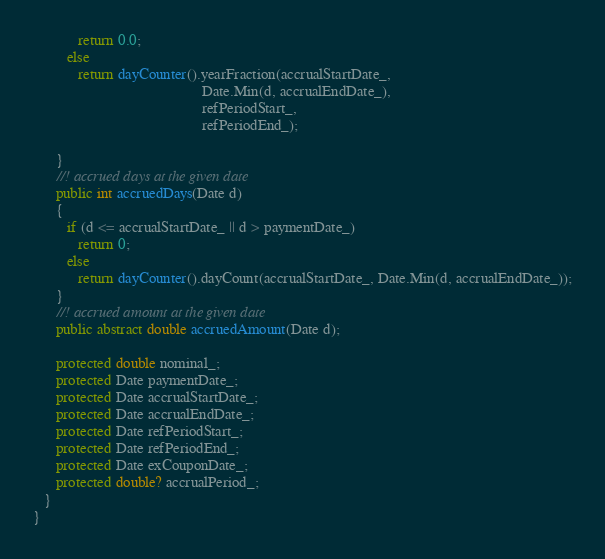Convert code to text. <code><loc_0><loc_0><loc_500><loc_500><_C#_>            return 0.0;
         else
            return dayCounter().yearFraction(accrualStartDate_,
                                             Date.Min(d, accrualEndDate_),
                                             refPeriodStart_,
                                             refPeriodEnd_);

      }
      //! accrued days at the given date
      public int accruedDays(Date d)
      {
         if (d <= accrualStartDate_ || d > paymentDate_)
            return 0;
         else
            return dayCounter().dayCount(accrualStartDate_, Date.Min(d, accrualEndDate_));
      }
      //! accrued amount at the given date
      public abstract double accruedAmount(Date d);

      protected double nominal_;
      protected Date paymentDate_;
      protected Date accrualStartDate_;
      protected Date accrualEndDate_;
      protected Date refPeriodStart_;
      protected Date refPeriodEnd_;
      protected Date exCouponDate_;
      protected double? accrualPeriod_;
   }
}
</code> 